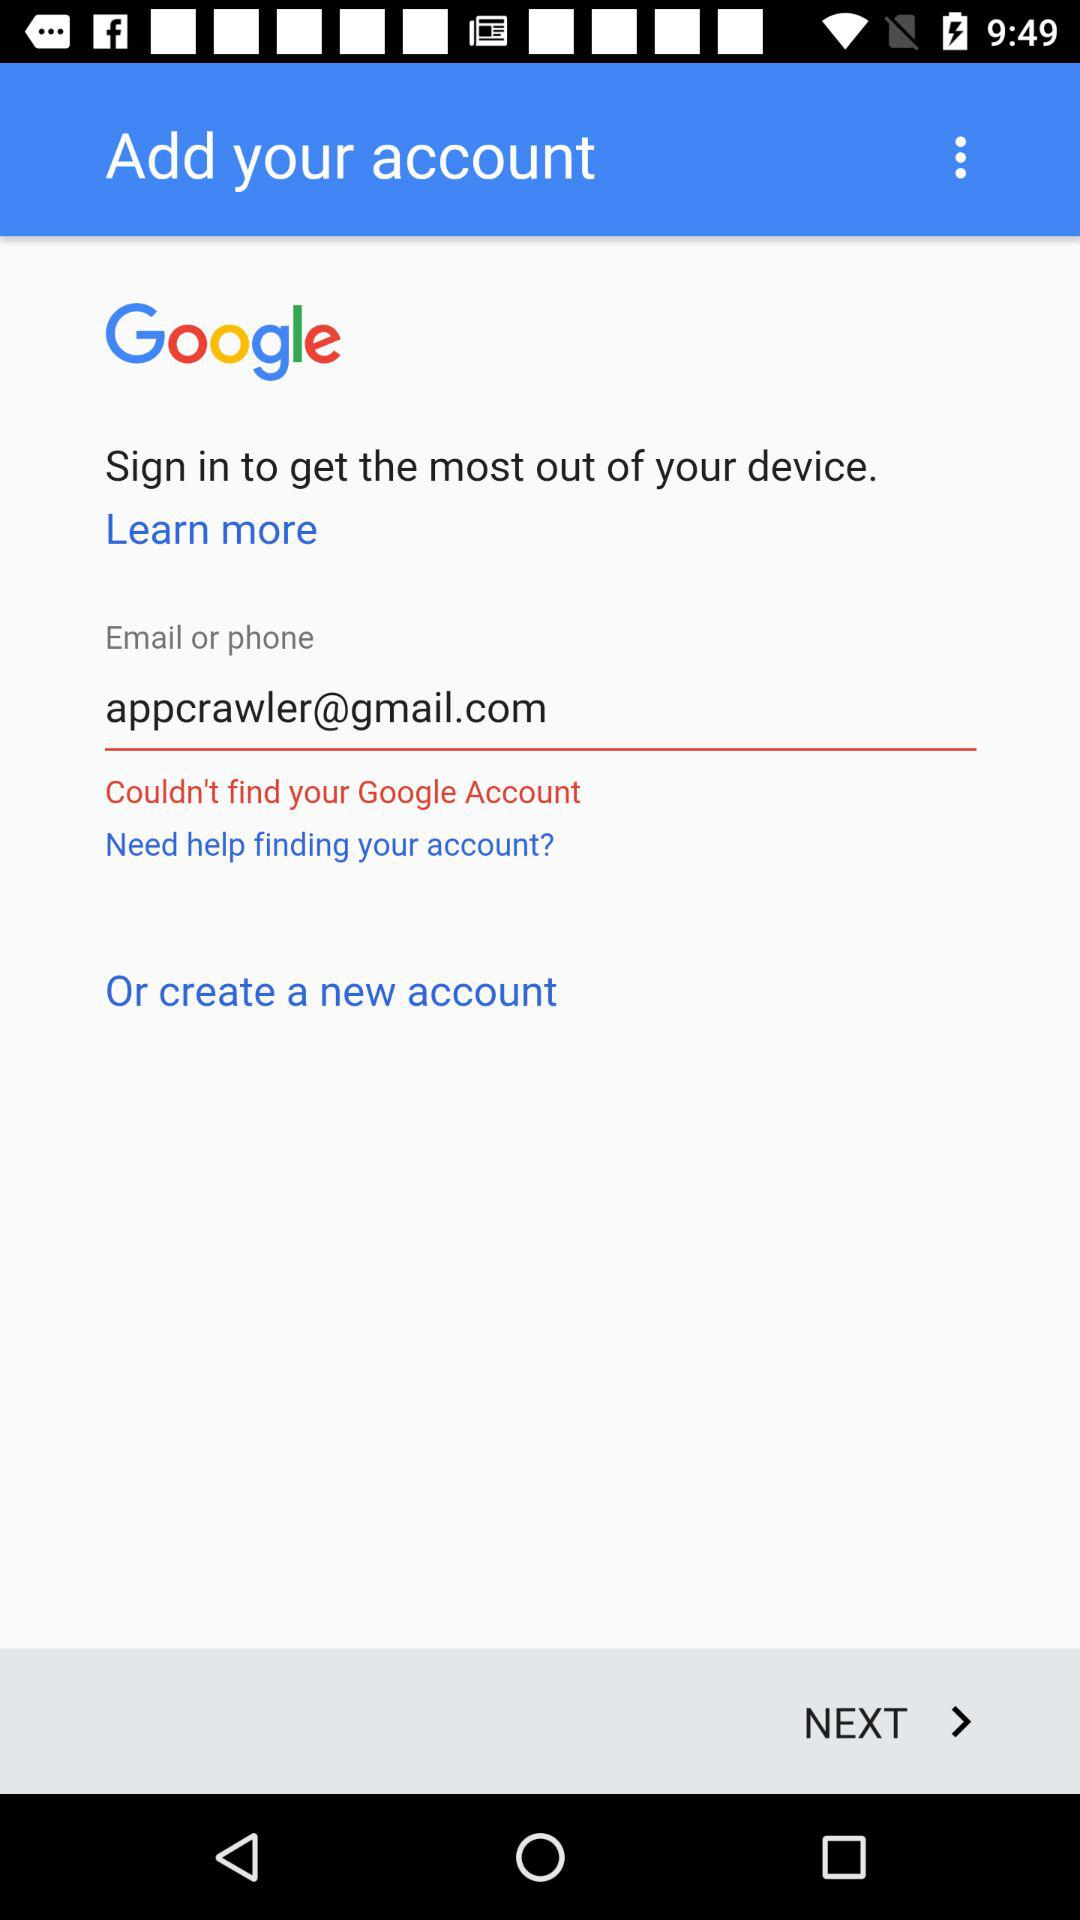What is used for signing in? For signing in the "Email" is used. 